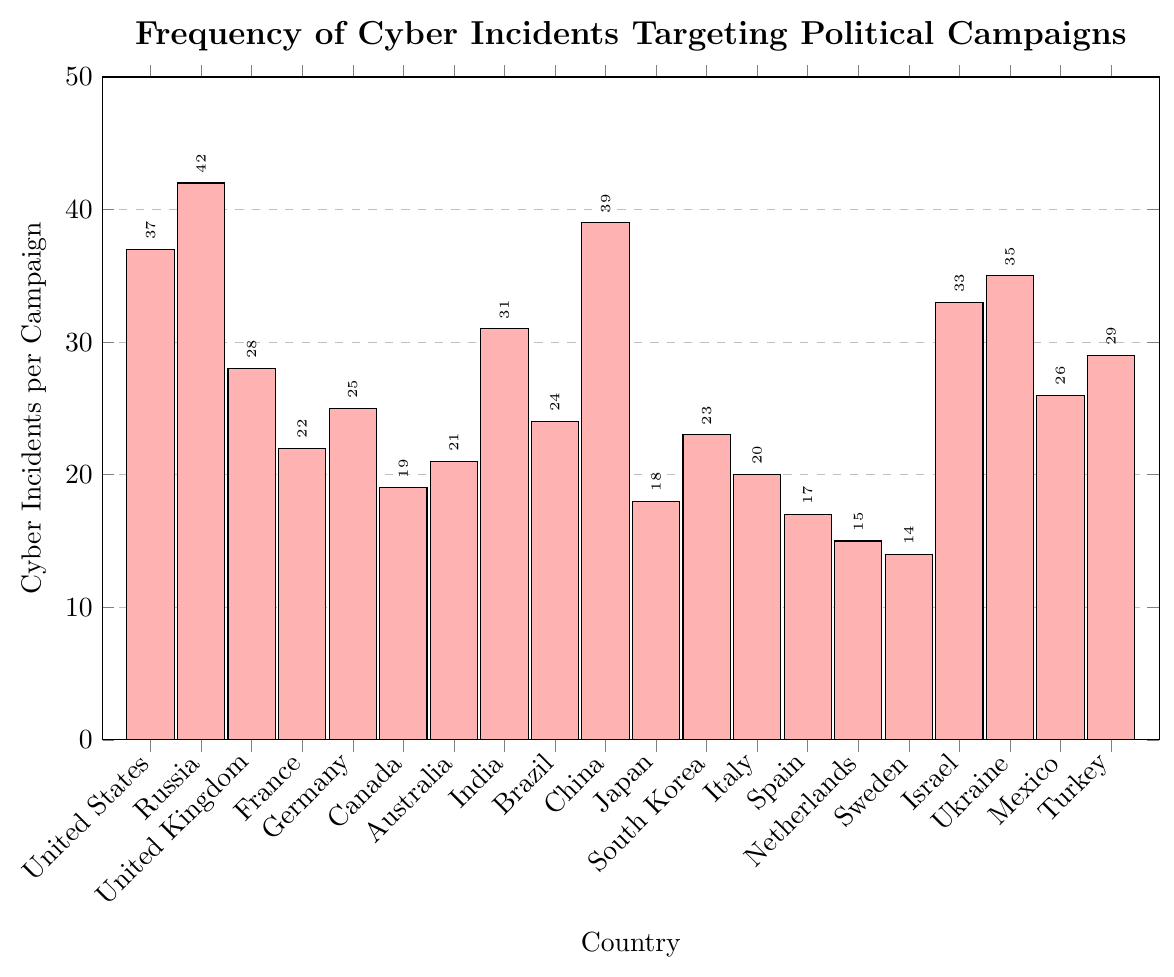Which country experienced the most frequent cyber incidents against political campaigns? Look at the height of the bars to determine the country with the highest value. The bar for Russia is the tallest, indicating 42 incidents.
Answer: Russia Compare cyber incidents between the United States and China. Which had more? Compare the heights of the bars and the values on top of the bars for the United States (37) and China (39).
Answer: China What is the total number of cyber incidents for France, Germany, and Italy combined? Add the values for France (22), Germany (25), and Italy (20). The total is 22 + 25 + 20 = 67.
Answer: 67 Which country had the least number of cyber incidents targeting political campaigns? Look for the shortest bar. The bar for Sweden is the shortest, indicating 14 incidents.
Answer: Sweden How many more cyber incidents did Russia have compared to the United Kingdom? Subtract the value for the United Kingdom (28) from Russia (42). The difference is 42 - 28 = 14.
Answer: 14 What is the average number of cyber incidents per campaign for the countries shown in the chart? Sum all the incidents and divide by the number of countries. The total is 37+42+28+22+25+19+21+31+24+39+18+23+20+17+15+14+33+35+26+29 = 518 and there are 20 countries, so 518 / 20 = 25.9.
Answer: 25.9 Is the number of cyber incidents in Turkey greater than in Japan? Compare the heights of the bars and the values for Turkey (29) and Japan (18).
Answer: Yes Identify three countries with the highest frequency of cyber incidents targeting political campaigns. Identify the highest bars. They belong to Russia (42), China (39), and the United States (37).
Answer: Russia, China, United States What is the difference in cyber incidents between Israel and Ukraine? Subtract the value for Israel (33) from Ukraine (35). The difference is 35 - 33 = 2.
Answer: 2 How do the cyber incidents in Canada compare to those in Italy? Compare the heights of the bars and the values for Canada (19) and Italy (20).
Answer: Italy has slightly more incidents 